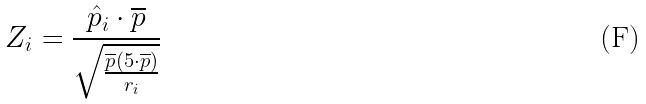Convert formula to latex. <formula><loc_0><loc_0><loc_500><loc_500>Z _ { i } = \frac { \hat { p } _ { i } \cdot \overline { p } } { \sqrt { \frac { \overline { p } ( 5 \cdot \overline { p } ) } { r _ { i } } } }</formula> 